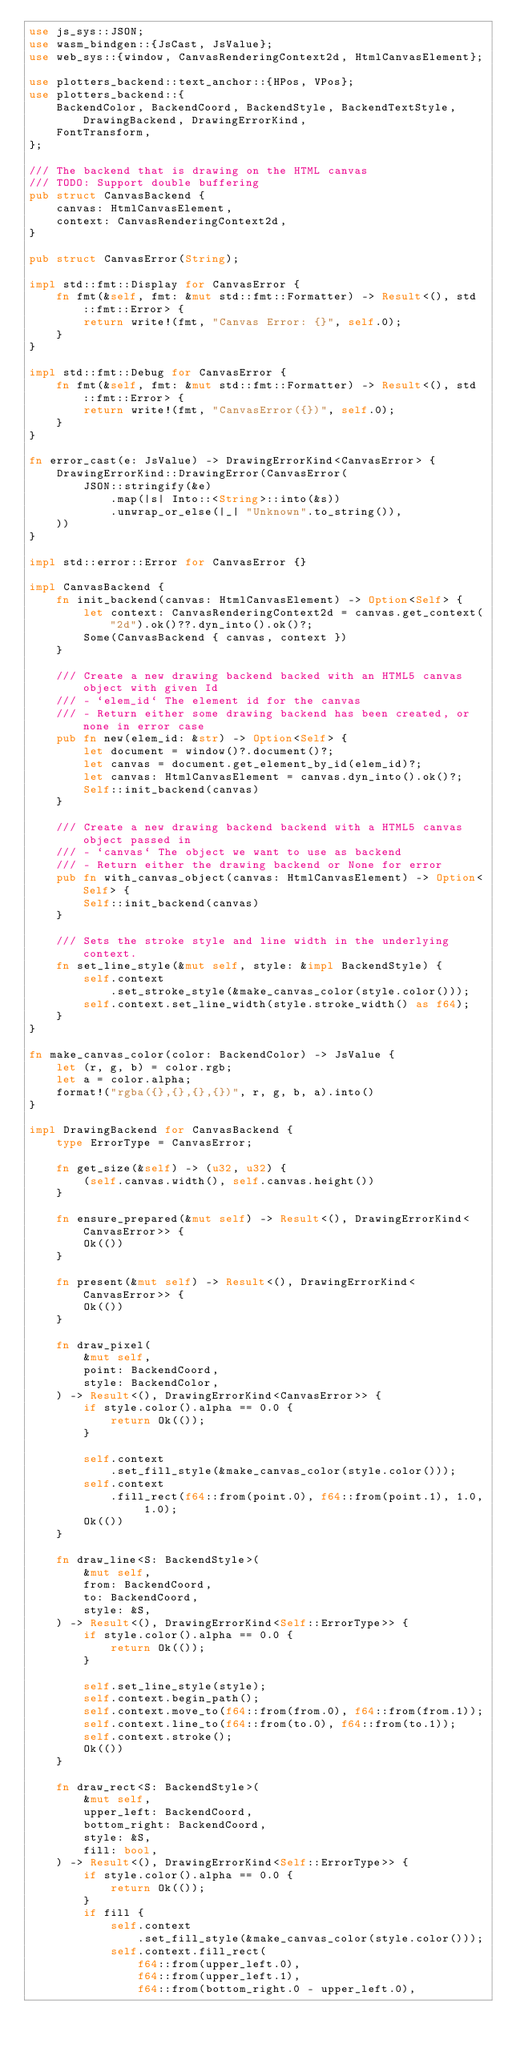Convert code to text. <code><loc_0><loc_0><loc_500><loc_500><_Rust_>use js_sys::JSON;
use wasm_bindgen::{JsCast, JsValue};
use web_sys::{window, CanvasRenderingContext2d, HtmlCanvasElement};

use plotters_backend::text_anchor::{HPos, VPos};
use plotters_backend::{
    BackendColor, BackendCoord, BackendStyle, BackendTextStyle, DrawingBackend, DrawingErrorKind,
    FontTransform,
};

/// The backend that is drawing on the HTML canvas
/// TODO: Support double buffering
pub struct CanvasBackend {
    canvas: HtmlCanvasElement,
    context: CanvasRenderingContext2d,
}

pub struct CanvasError(String);

impl std::fmt::Display for CanvasError {
    fn fmt(&self, fmt: &mut std::fmt::Formatter) -> Result<(), std::fmt::Error> {
        return write!(fmt, "Canvas Error: {}", self.0);
    }
}

impl std::fmt::Debug for CanvasError {
    fn fmt(&self, fmt: &mut std::fmt::Formatter) -> Result<(), std::fmt::Error> {
        return write!(fmt, "CanvasError({})", self.0);
    }
}

fn error_cast(e: JsValue) -> DrawingErrorKind<CanvasError> {
    DrawingErrorKind::DrawingError(CanvasError(
        JSON::stringify(&e)
            .map(|s| Into::<String>::into(&s))
            .unwrap_or_else(|_| "Unknown".to_string()),
    ))
}

impl std::error::Error for CanvasError {}

impl CanvasBackend {
    fn init_backend(canvas: HtmlCanvasElement) -> Option<Self> {
        let context: CanvasRenderingContext2d = canvas.get_context("2d").ok()??.dyn_into().ok()?;
        Some(CanvasBackend { canvas, context })
    }

    /// Create a new drawing backend backed with an HTML5 canvas object with given Id
    /// - `elem_id` The element id for the canvas
    /// - Return either some drawing backend has been created, or none in error case
    pub fn new(elem_id: &str) -> Option<Self> {
        let document = window()?.document()?;
        let canvas = document.get_element_by_id(elem_id)?;
        let canvas: HtmlCanvasElement = canvas.dyn_into().ok()?;
        Self::init_backend(canvas)
    }

    /// Create a new drawing backend backend with a HTML5 canvas object passed in
    /// - `canvas` The object we want to use as backend
    /// - Return either the drawing backend or None for error
    pub fn with_canvas_object(canvas: HtmlCanvasElement) -> Option<Self> {
        Self::init_backend(canvas)
    }

    /// Sets the stroke style and line width in the underlying context.
    fn set_line_style(&mut self, style: &impl BackendStyle) {
        self.context
            .set_stroke_style(&make_canvas_color(style.color()));
        self.context.set_line_width(style.stroke_width() as f64);
    }
}

fn make_canvas_color(color: BackendColor) -> JsValue {
    let (r, g, b) = color.rgb;
    let a = color.alpha;
    format!("rgba({},{},{},{})", r, g, b, a).into()
}

impl DrawingBackend for CanvasBackend {
    type ErrorType = CanvasError;

    fn get_size(&self) -> (u32, u32) {
        (self.canvas.width(), self.canvas.height())
    }

    fn ensure_prepared(&mut self) -> Result<(), DrawingErrorKind<CanvasError>> {
        Ok(())
    }

    fn present(&mut self) -> Result<(), DrawingErrorKind<CanvasError>> {
        Ok(())
    }

    fn draw_pixel(
        &mut self,
        point: BackendCoord,
        style: BackendColor,
    ) -> Result<(), DrawingErrorKind<CanvasError>> {
        if style.color().alpha == 0.0 {
            return Ok(());
        }

        self.context
            .set_fill_style(&make_canvas_color(style.color()));
        self.context
            .fill_rect(f64::from(point.0), f64::from(point.1), 1.0, 1.0);
        Ok(())
    }

    fn draw_line<S: BackendStyle>(
        &mut self,
        from: BackendCoord,
        to: BackendCoord,
        style: &S,
    ) -> Result<(), DrawingErrorKind<Self::ErrorType>> {
        if style.color().alpha == 0.0 {
            return Ok(());
        }

        self.set_line_style(style);
        self.context.begin_path();
        self.context.move_to(f64::from(from.0), f64::from(from.1));
        self.context.line_to(f64::from(to.0), f64::from(to.1));
        self.context.stroke();
        Ok(())
    }

    fn draw_rect<S: BackendStyle>(
        &mut self,
        upper_left: BackendCoord,
        bottom_right: BackendCoord,
        style: &S,
        fill: bool,
    ) -> Result<(), DrawingErrorKind<Self::ErrorType>> {
        if style.color().alpha == 0.0 {
            return Ok(());
        }
        if fill {
            self.context
                .set_fill_style(&make_canvas_color(style.color()));
            self.context.fill_rect(
                f64::from(upper_left.0),
                f64::from(upper_left.1),
                f64::from(bottom_right.0 - upper_left.0),</code> 